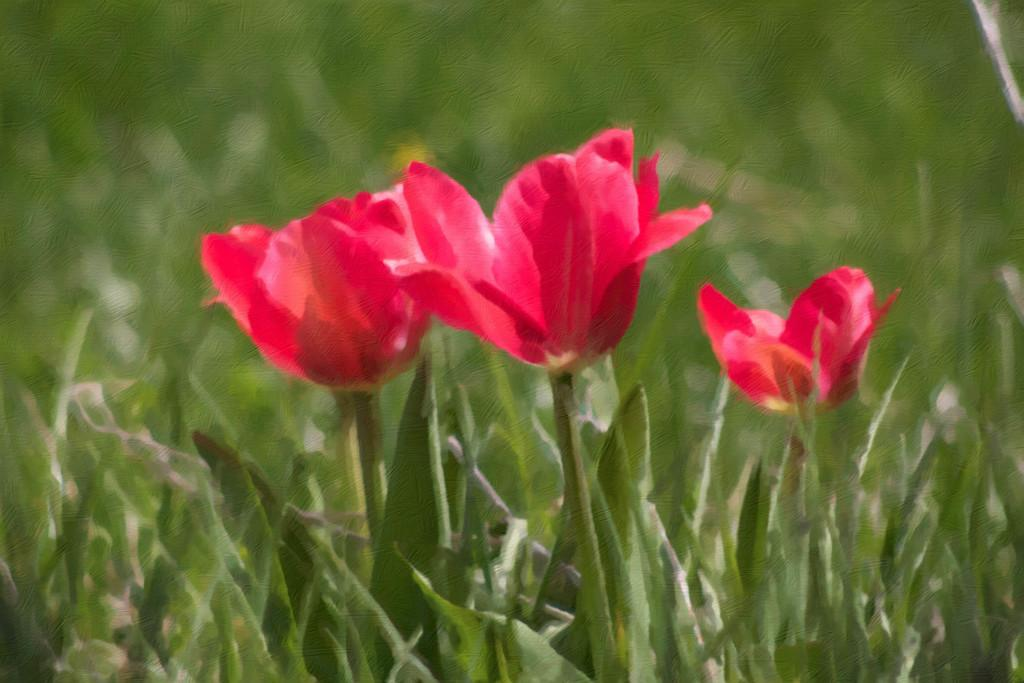What type of plants can be seen in the image? There are flower plants in the image. Can you describe the appearance of the flower plants? The flower plants have colorful blooms and green foliage. Are there any other objects or elements visible in the image? The image only shows flower plants. What type of jelly can be seen on the trousers in the image? There is no jelly or trousers present in the image; it only features flower plants. 